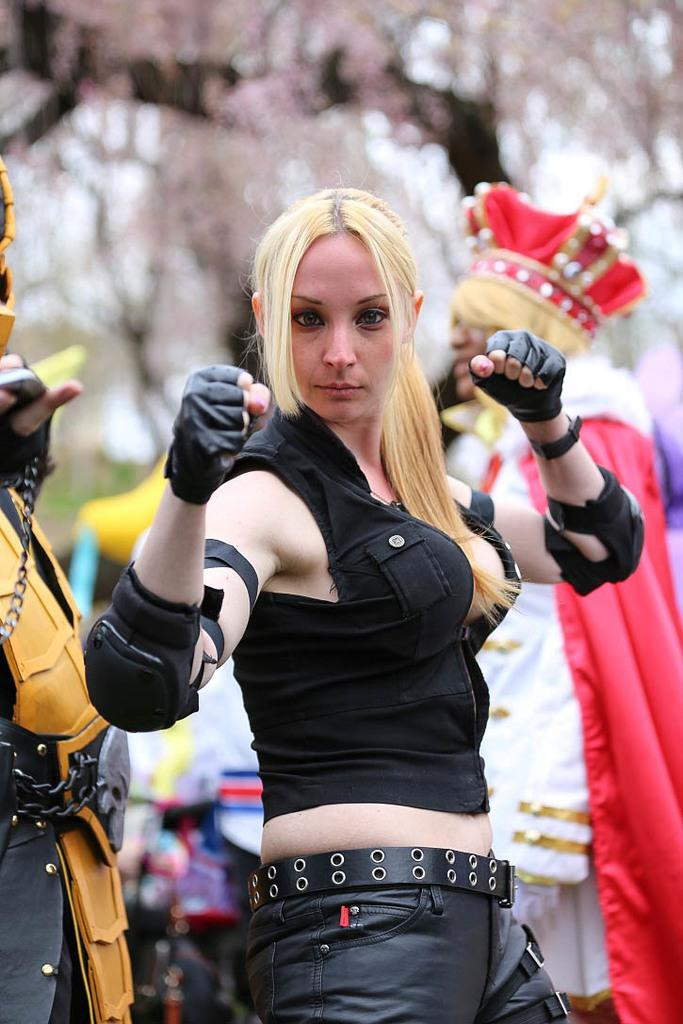Who or what is present in the image? There are people in the image. What are the people wearing? The people are wearing costumes. What natural element can be seen in the image? There is a tree visible in the image. What type of flora is present in the image? There are flowers in the image. How many cakes are being held by the people in the image? There is no mention of cakes in the image; the people are wearing costumes and there are flowers and a tree present. 